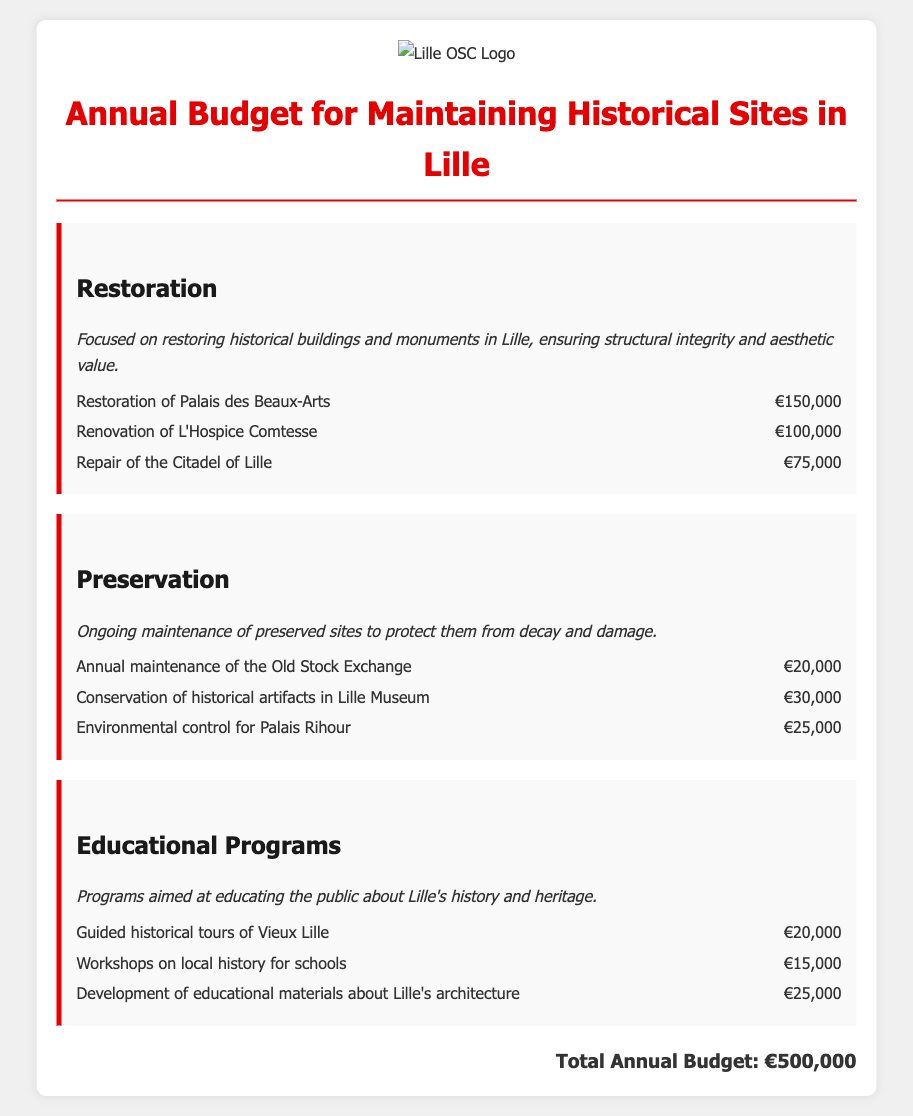What is the total annual budget? The total annual budget is mentioned at the bottom of the document, summarizing all expenses across categories.
Answer: €500,000 How much is allocated for the restoration of Palais des Beaux-Arts? The document lists the specific allocation for the restoration of Palais des Beaux-Arts under the Restoration category.
Answer: €150,000 What is the budget for workshops on local history for schools? The amount is detailed in the Educational Programs section, showing the budget specifically for workshops on local history.
Answer: €15,000 How many historical categories are there in the budget? The document presents three main categories for the budget allocation: Restoration, Preservation, and Educational Programs.
Answer: 3 What is the budget allocated for the annual maintenance of the Old Stock Exchange? This figure details the specific budget set aside for the maintenance of the Old Stock Exchange under the Preservation category.
Answer: €20,000 What is the total amount allocated for preservation activities? This requires summing up all preservation-related budget items listed in the document.
Answer: €75,000 What type of educational programs are funded? The document describes various programs aimed at educating the public about Lille's history and heritage under the Educational Programs section.
Answer: Guided historical tours, workshops, educational materials Which site has a budget for environmental control? This information is derived from the specific item listed under the Preservation section regarding environmental control measures.
Answer: Palais Rihour 